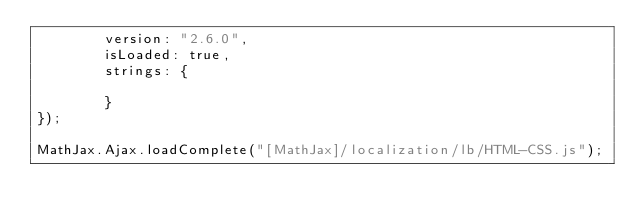Convert code to text. <code><loc_0><loc_0><loc_500><loc_500><_JavaScript_>        version: "2.6.0",
        isLoaded: true,
        strings: {

        }
});

MathJax.Ajax.loadComplete("[MathJax]/localization/lb/HTML-CSS.js");
</code> 